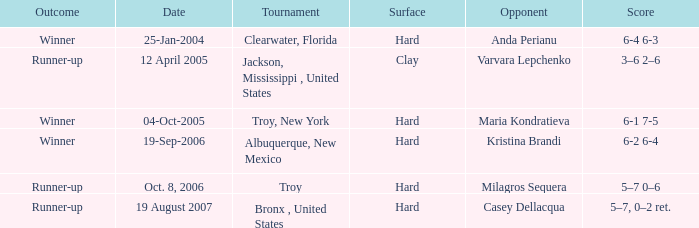Parse the table in full. {'header': ['Outcome', 'Date', 'Tournament', 'Surface', 'Opponent', 'Score'], 'rows': [['Winner', '25-Jan-2004', 'Clearwater, Florida', 'Hard', 'Anda Perianu', '6-4 6-3'], ['Runner-up', '12 April 2005', 'Jackson, Mississippi , United States', 'Clay', 'Varvara Lepchenko', '3–6 2–6'], ['Winner', '04-Oct-2005', 'Troy, New York', 'Hard', 'Maria Kondratieva', '6-1 7-5'], ['Winner', '19-Sep-2006', 'Albuquerque, New Mexico', 'Hard', 'Kristina Brandi', '6-2 6-4'], ['Runner-up', 'Oct. 8, 2006', 'Troy', 'Hard', 'Milagros Sequera', '5–7 0–6'], ['Runner-up', '19 August 2007', 'Bronx , United States', 'Hard', 'Casey Dellacqua', '5–7, 0–2 ret.']]} What is the final score of the tournament played in Clearwater, Florida? 6-4 6-3. 